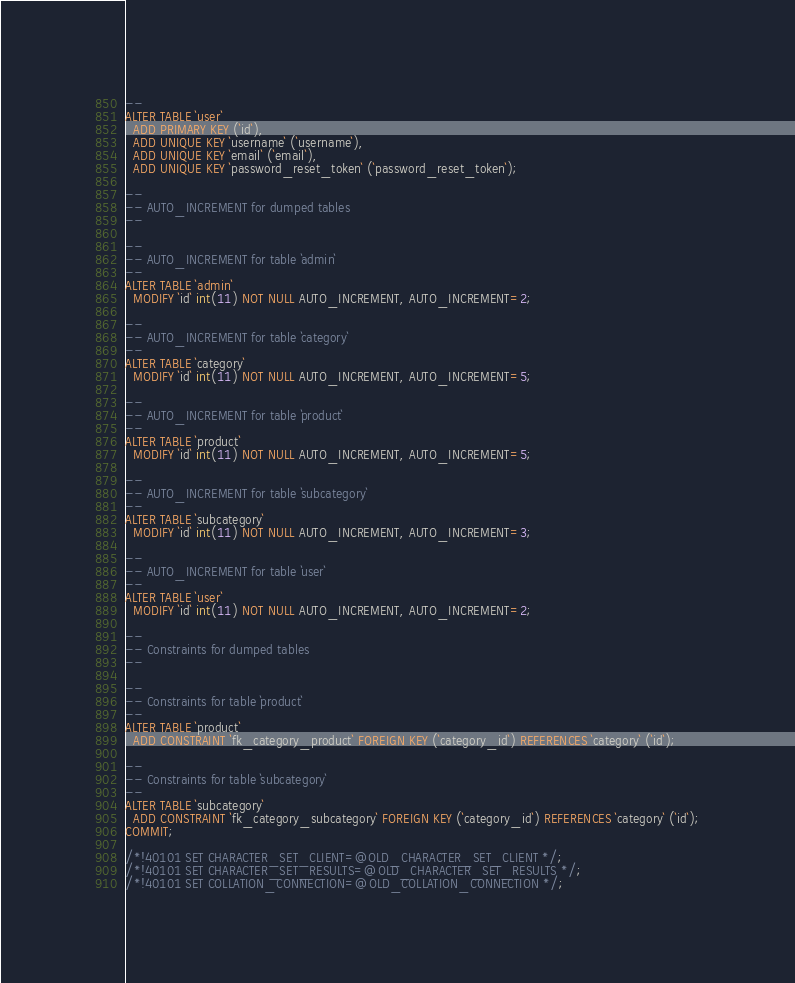<code> <loc_0><loc_0><loc_500><loc_500><_SQL_>--
ALTER TABLE `user`
  ADD PRIMARY KEY (`id`),
  ADD UNIQUE KEY `username` (`username`),
  ADD UNIQUE KEY `email` (`email`),
  ADD UNIQUE KEY `password_reset_token` (`password_reset_token`);

--
-- AUTO_INCREMENT for dumped tables
--

--
-- AUTO_INCREMENT for table `admin`
--
ALTER TABLE `admin`
  MODIFY `id` int(11) NOT NULL AUTO_INCREMENT, AUTO_INCREMENT=2;

--
-- AUTO_INCREMENT for table `category`
--
ALTER TABLE `category`
  MODIFY `id` int(11) NOT NULL AUTO_INCREMENT, AUTO_INCREMENT=5;

--
-- AUTO_INCREMENT for table `product`
--
ALTER TABLE `product`
  MODIFY `id` int(11) NOT NULL AUTO_INCREMENT, AUTO_INCREMENT=5;

--
-- AUTO_INCREMENT for table `subcategory`
--
ALTER TABLE `subcategory`
  MODIFY `id` int(11) NOT NULL AUTO_INCREMENT, AUTO_INCREMENT=3;

--
-- AUTO_INCREMENT for table `user`
--
ALTER TABLE `user`
  MODIFY `id` int(11) NOT NULL AUTO_INCREMENT, AUTO_INCREMENT=2;

--
-- Constraints for dumped tables
--

--
-- Constraints for table `product`
--
ALTER TABLE `product`
  ADD CONSTRAINT `fk_category_product` FOREIGN KEY (`category_id`) REFERENCES `category` (`id`);

--
-- Constraints for table `subcategory`
--
ALTER TABLE `subcategory`
  ADD CONSTRAINT `fk_category_subcategory` FOREIGN KEY (`category_id`) REFERENCES `category` (`id`);
COMMIT;

/*!40101 SET CHARACTER_SET_CLIENT=@OLD_CHARACTER_SET_CLIENT */;
/*!40101 SET CHARACTER_SET_RESULTS=@OLD_CHARACTER_SET_RESULTS */;
/*!40101 SET COLLATION_CONNECTION=@OLD_COLLATION_CONNECTION */;
</code> 